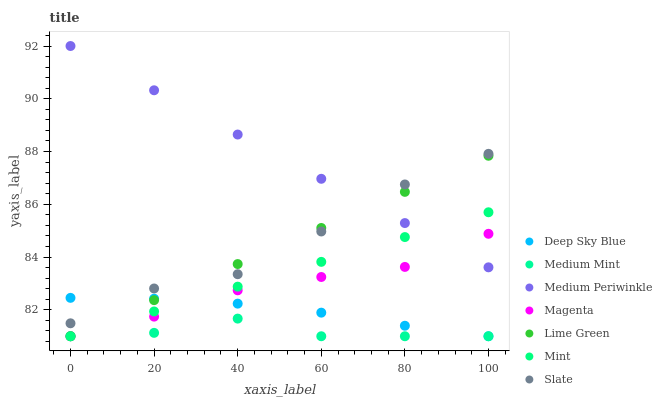Does Medium Mint have the minimum area under the curve?
Answer yes or no. Yes. Does Medium Periwinkle have the maximum area under the curve?
Answer yes or no. Yes. Does Mint have the minimum area under the curve?
Answer yes or no. No. Does Mint have the maximum area under the curve?
Answer yes or no. No. Is Medium Periwinkle the smoothest?
Answer yes or no. Yes. Is Slate the roughest?
Answer yes or no. Yes. Is Mint the smoothest?
Answer yes or no. No. Is Mint the roughest?
Answer yes or no. No. Does Medium Mint have the lowest value?
Answer yes or no. Yes. Does Slate have the lowest value?
Answer yes or no. No. Does Medium Periwinkle have the highest value?
Answer yes or no. Yes. Does Mint have the highest value?
Answer yes or no. No. Is Magenta less than Slate?
Answer yes or no. Yes. Is Medium Periwinkle greater than Deep Sky Blue?
Answer yes or no. Yes. Does Magenta intersect Medium Mint?
Answer yes or no. Yes. Is Magenta less than Medium Mint?
Answer yes or no. No. Is Magenta greater than Medium Mint?
Answer yes or no. No. Does Magenta intersect Slate?
Answer yes or no. No. 